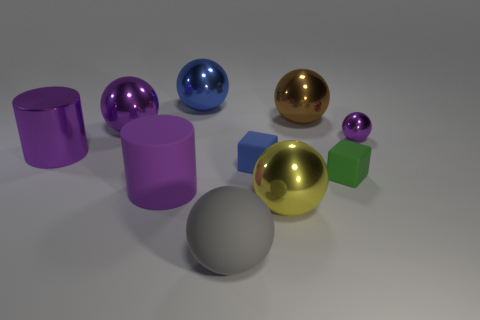Subtract all big brown metallic balls. How many balls are left? 5 Subtract all cyan blocks. How many purple spheres are left? 2 Subtract all green blocks. How many blocks are left? 1 Add 5 large purple metal things. How many large purple metal things exist? 7 Subtract 1 blue blocks. How many objects are left? 9 Subtract all cubes. How many objects are left? 8 Subtract 2 cylinders. How many cylinders are left? 0 Subtract all green cylinders. Subtract all blue blocks. How many cylinders are left? 2 Subtract all small blue spheres. Subtract all tiny purple balls. How many objects are left? 9 Add 6 purple objects. How many purple objects are left? 10 